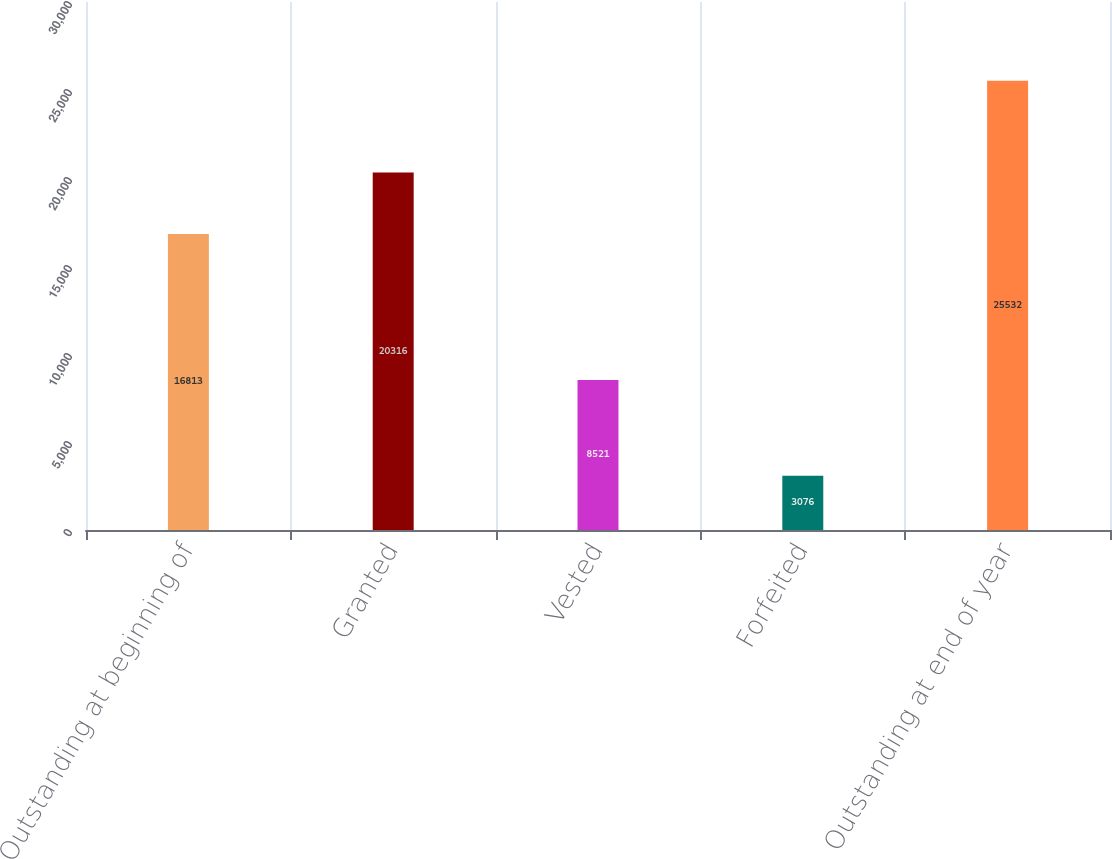<chart> <loc_0><loc_0><loc_500><loc_500><bar_chart><fcel>Outstanding at beginning of<fcel>Granted<fcel>Vested<fcel>Forfeited<fcel>Outstanding at end of year<nl><fcel>16813<fcel>20316<fcel>8521<fcel>3076<fcel>25532<nl></chart> 